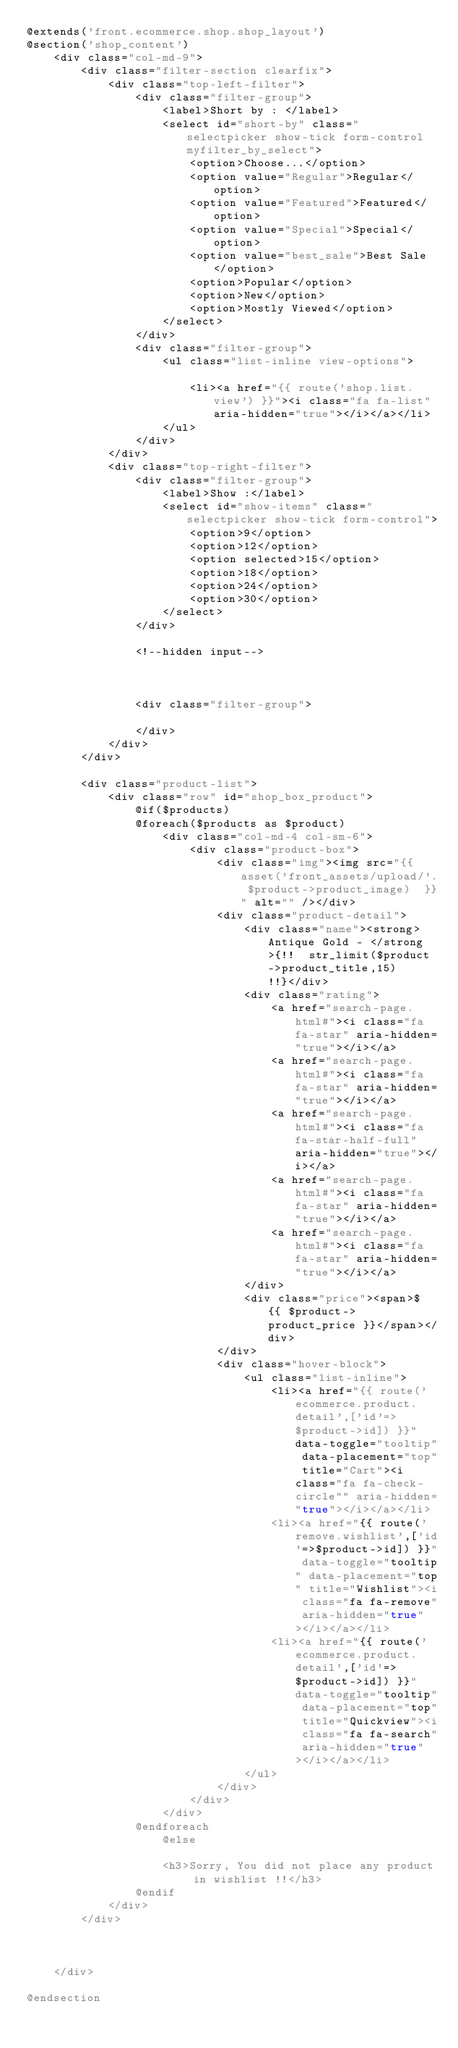<code> <loc_0><loc_0><loc_500><loc_500><_PHP_>@extends('front.ecommerce.shop.shop_layout')
@section('shop_content')
    <div class="col-md-9">
        <div class="filter-section clearfix">
            <div class="top-left-filter">
                <div class="filter-group">
                    <label>Short by : </label>
                    <select id="short-by" class="selectpicker show-tick form-control myfilter_by_select">
                        <option>Choose...</option>
                        <option value="Regular">Regular</option>
                        <option value="Featured">Featured</option>
                        <option value="Special">Special</option>
                        <option value="best_sale">Best Sale</option>
                        <option>Popular</option>
                        <option>New</option>
                        <option>Mostly Viewed</option>
                    </select>
                </div>
                <div class="filter-group">
                    <ul class="list-inline view-options">

                        <li><a href="{{ route('shop.list.view') }}"><i class="fa fa-list" aria-hidden="true"></i></a></li>
                    </ul>
                </div>
            </div>
            <div class="top-right-filter">
                <div class="filter-group">
                    <label>Show :</label>
                    <select id="show-items" class="selectpicker show-tick form-control">
                        <option>9</option>
                        <option>12</option>
                        <option selected>15</option>
                        <option>18</option>
                        <option>24</option>
                        <option>30</option>
                    </select>
                </div>

                <!--hidden input-->



                <div class="filter-group">

                </div>
            </div>
        </div>

        <div class="product-list">
            <div class="row" id="shop_box_product">
                @if($products)
                @foreach($products as $product)
                    <div class="col-md-4 col-sm-6">
                        <div class="product-box">
                            <div class="img"><img src="{{ asset('front_assets/upload/'. $product->product_image)  }}" alt="" /></div>
                            <div class="product-detail">
                                <div class="name"><strong>Antique Gold - </strong>{!!  str_limit($product->product_title,15)  !!}</div>
                                <div class="rating">
                                    <a href="search-page.html#"><i class="fa fa-star" aria-hidden="true"></i></a>
                                    <a href="search-page.html#"><i class="fa fa-star" aria-hidden="true"></i></a>
                                    <a href="search-page.html#"><i class="fa fa-star-half-full" aria-hidden="true"></i></a>
                                    <a href="search-page.html#"><i class="fa fa-star" aria-hidden="true"></i></a>
                                    <a href="search-page.html#"><i class="fa fa-star" aria-hidden="true"></i></a>
                                </div>
                                <div class="price"><span>$ {{ $product->product_price }}</span></div>
                            </div>
                            <div class="hover-block">
                                <ul class="list-inline">
                                    <li><a href="{{ route('ecommerce.product.detail',['id'=>$product->id]) }}" data-toggle="tooltip" data-placement="top" title="Cart"><i class="fa fa-check-circle"" aria-hidden="true"></i></a></li>
                                    <li><a href="{{ route('remove.wishlist',['id'=>$product->id]) }}" data-toggle="tooltip" data-placement="top" title="Wishlist"><i class="fa fa-remove" aria-hidden="true"></i></a></li>
                                    <li><a href="{{ route('ecommerce.product.detail',['id'=>$product->id]) }}" data-toggle="tooltip" data-placement="top" title="Quickview"><i class="fa fa-search" aria-hidden="true"></i></a></li>
                                </ul>
                            </div>
                        </div>
                    </div>
                @endforeach
                    @else

                    <h3>Sorry, You did not place any product in wishlist !!</h3>
                @endif
            </div>
        </div>



    </div>

@endsection

</code> 